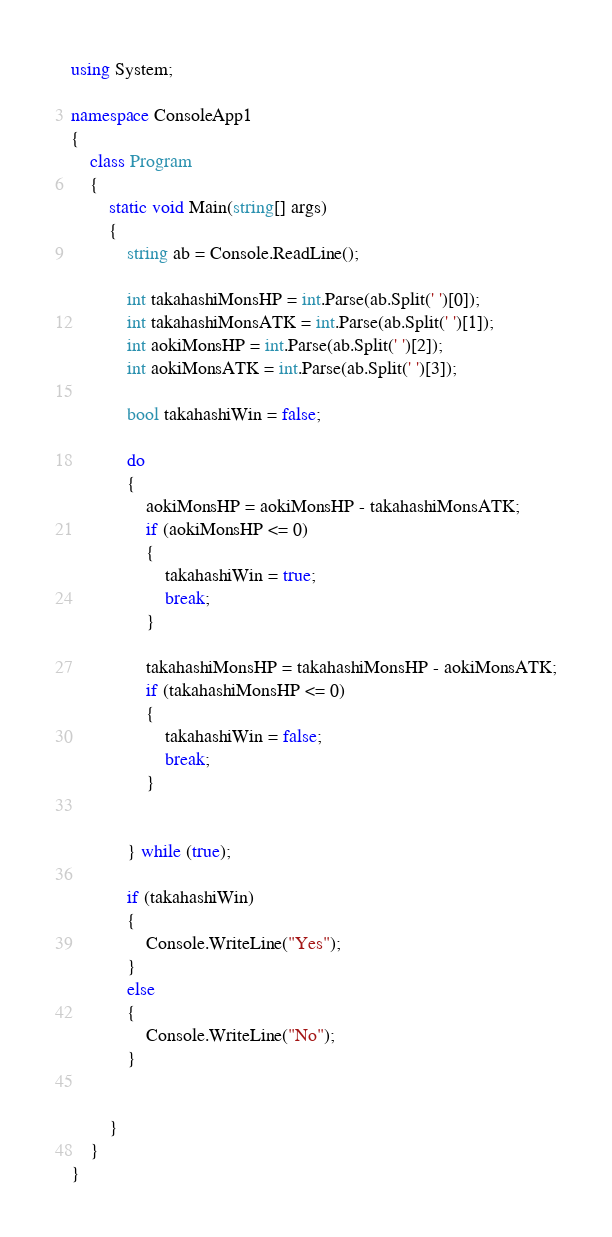Convert code to text. <code><loc_0><loc_0><loc_500><loc_500><_C#_>using System;

namespace ConsoleApp1
{
    class Program
    {
        static void Main(string[] args)
        {
            string ab = Console.ReadLine();

            int takahashiMonsHP = int.Parse(ab.Split(' ')[0]);
            int takahashiMonsATK = int.Parse(ab.Split(' ')[1]);
            int aokiMonsHP = int.Parse(ab.Split(' ')[2]);
            int aokiMonsATK = int.Parse(ab.Split(' ')[3]);

            bool takahashiWin = false;

            do
            {
                aokiMonsHP = aokiMonsHP - takahashiMonsATK;
                if (aokiMonsHP <= 0)
                {
                    takahashiWin = true;
                    break;
                }

                takahashiMonsHP = takahashiMonsHP - aokiMonsATK;
                if (takahashiMonsHP <= 0)
                {
                    takahashiWin = false;
                    break;
                }


            } while (true);

            if (takahashiWin)
            {
                Console.WriteLine("Yes");
            }
            else
            {
                Console.WriteLine("No");
            }


        }
    }
}
</code> 